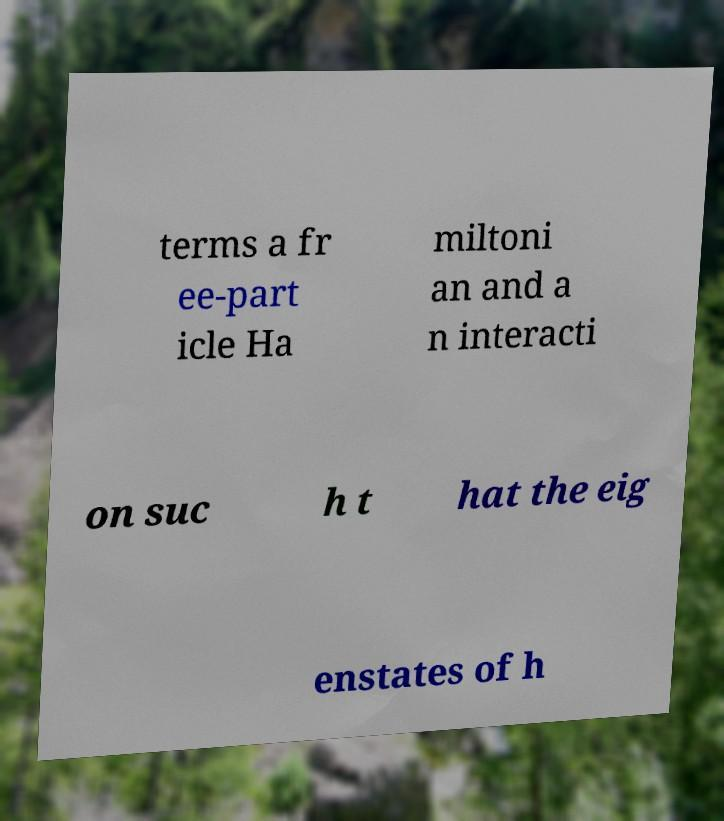Can you read and provide the text displayed in the image?This photo seems to have some interesting text. Can you extract and type it out for me? terms a fr ee-part icle Ha miltoni an and a n interacti on suc h t hat the eig enstates of h 